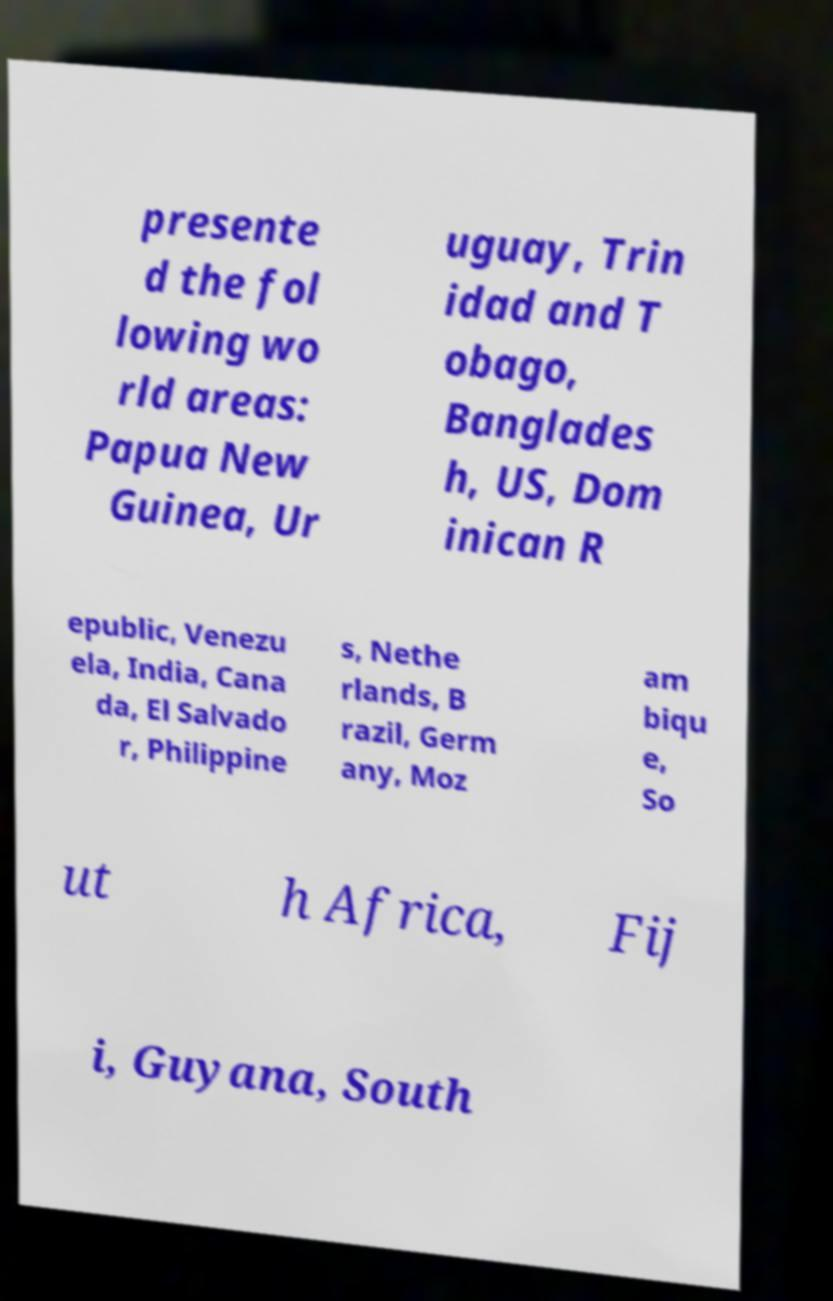There's text embedded in this image that I need extracted. Can you transcribe it verbatim? presente d the fol lowing wo rld areas: Papua New Guinea, Ur uguay, Trin idad and T obago, Banglades h, US, Dom inican R epublic, Venezu ela, India, Cana da, El Salvado r, Philippine s, Nethe rlands, B razil, Germ any, Moz am biqu e, So ut h Africa, Fij i, Guyana, South 